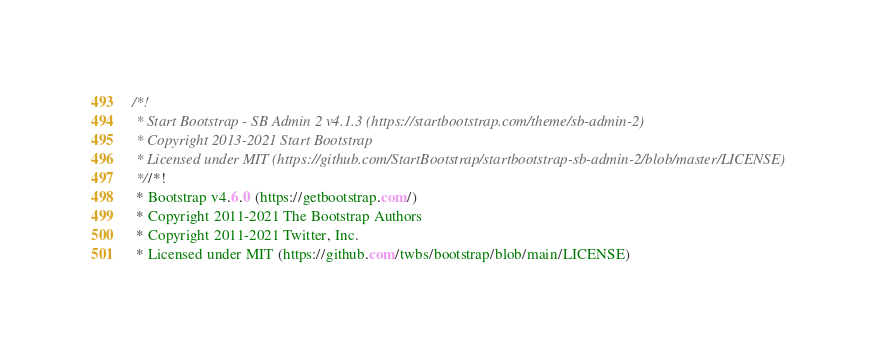<code> <loc_0><loc_0><loc_500><loc_500><_CSS_>/*!
 * Start Bootstrap - SB Admin 2 v4.1.3 (https://startbootstrap.com/theme/sb-admin-2)
 * Copyright 2013-2021 Start Bootstrap
 * Licensed under MIT (https://github.com/StartBootstrap/startbootstrap-sb-admin-2/blob/master/LICENSE)
 *//*!
 * Bootstrap v4.6.0 (https://getbootstrap.com/)
 * Copyright 2011-2021 The Bootstrap Authors
 * Copyright 2011-2021 Twitter, Inc.
 * Licensed under MIT (https://github.com/twbs/bootstrap/blob/main/LICENSE)</code> 